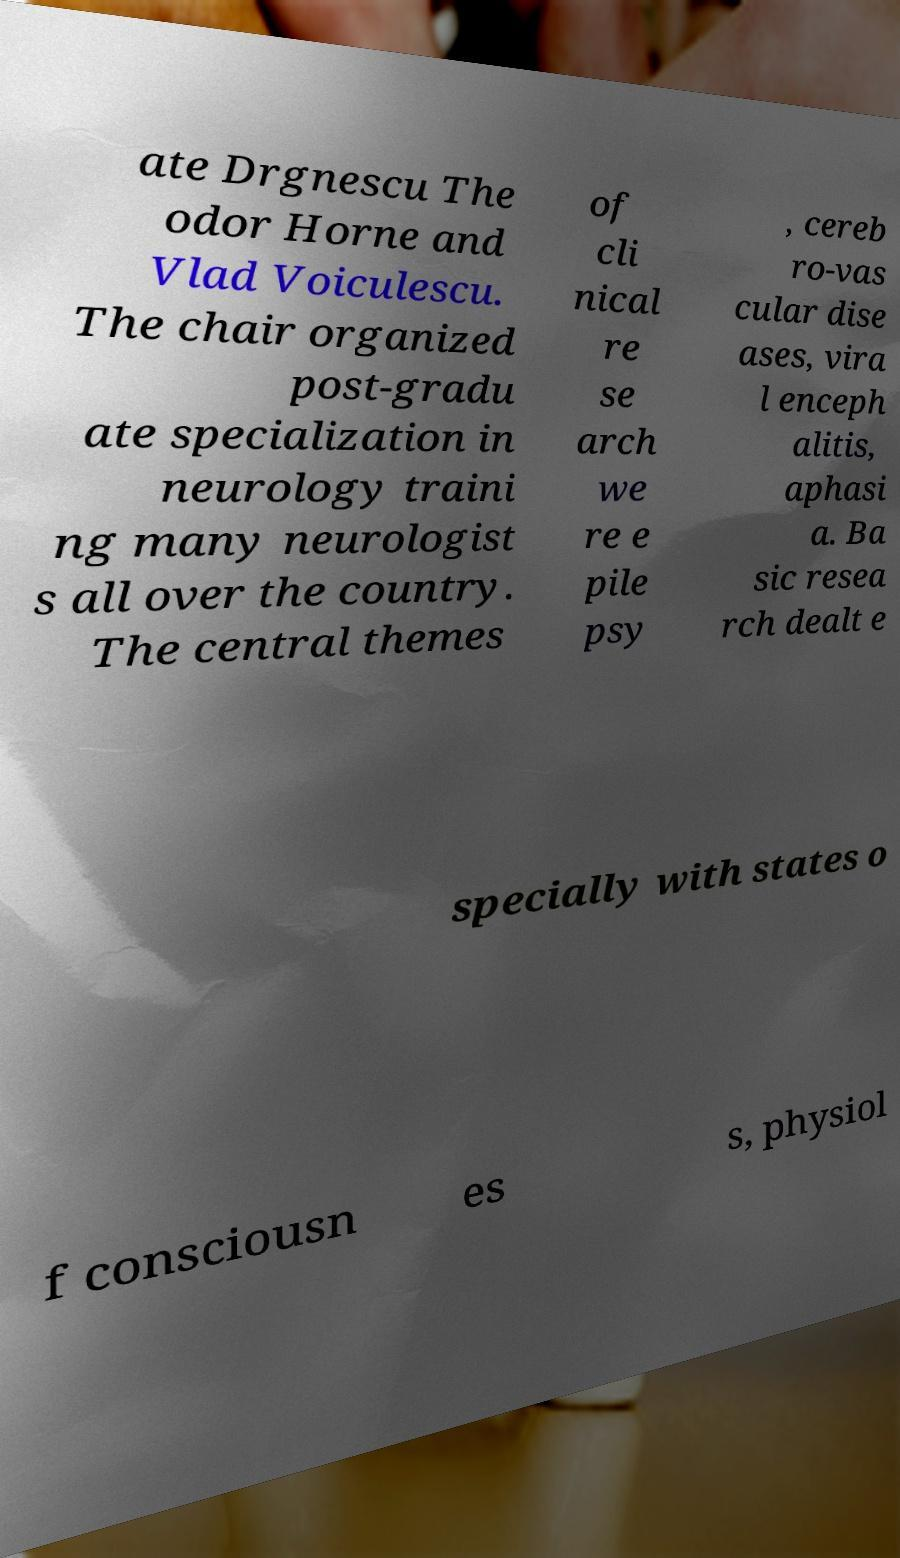Can you accurately transcribe the text from the provided image for me? ate Drgnescu The odor Horne and Vlad Voiculescu. The chair organized post-gradu ate specialization in neurology traini ng many neurologist s all over the country. The central themes of cli nical re se arch we re e pile psy , cereb ro-vas cular dise ases, vira l enceph alitis, aphasi a. Ba sic resea rch dealt e specially with states o f consciousn es s, physiol 